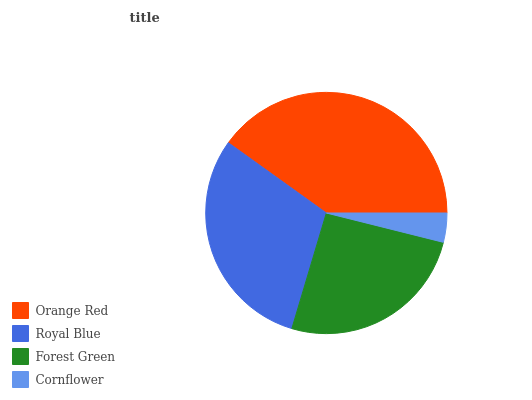Is Cornflower the minimum?
Answer yes or no. Yes. Is Orange Red the maximum?
Answer yes or no. Yes. Is Royal Blue the minimum?
Answer yes or no. No. Is Royal Blue the maximum?
Answer yes or no. No. Is Orange Red greater than Royal Blue?
Answer yes or no. Yes. Is Royal Blue less than Orange Red?
Answer yes or no. Yes. Is Royal Blue greater than Orange Red?
Answer yes or no. No. Is Orange Red less than Royal Blue?
Answer yes or no. No. Is Royal Blue the high median?
Answer yes or no. Yes. Is Forest Green the low median?
Answer yes or no. Yes. Is Forest Green the high median?
Answer yes or no. No. Is Orange Red the low median?
Answer yes or no. No. 